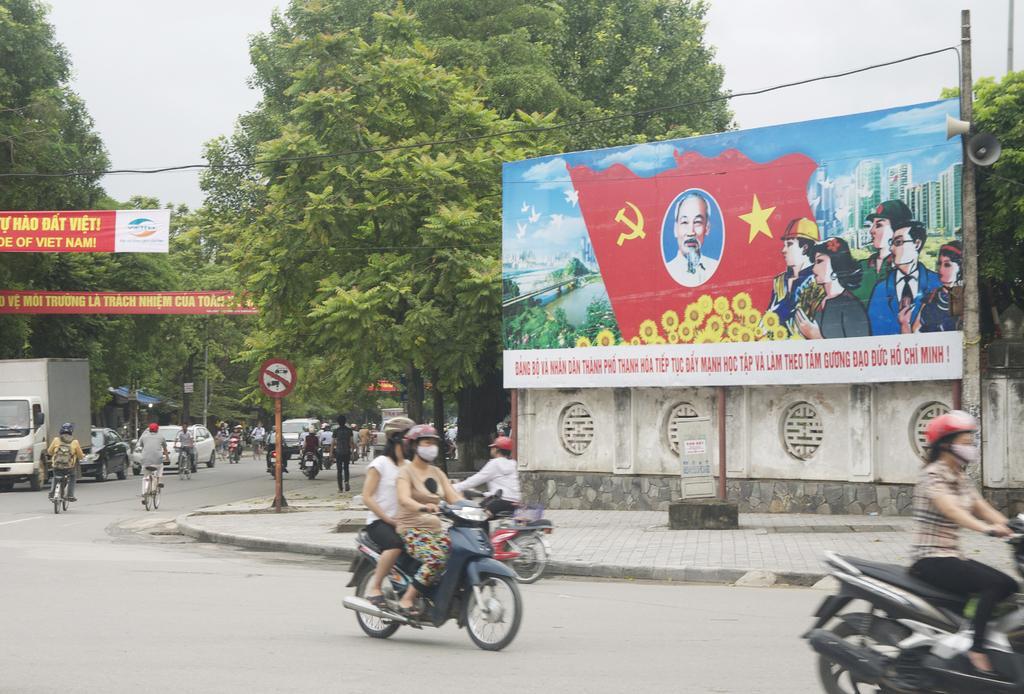How would you summarize this image in a sentence or two? There were too many vehicles moving on a road. To the right there is a bike and a woman riding on it wears a red helmet. In the center there is a bike and two people were riding on it and there were helmets and beside them,there is a bike and a person riding on it and he wears a red helmet. To the top right there is a hoarding consists of a person's, symbols, flowers, birds, bridge, buildings and group of cartoons and a printed text on it. There are two sound speakers attached to the hoarding. In the background there were two trees. To the left there are two banners and printed text on it. To the bottom left there are group of vehicles consists of truck, bicycles, car and bikes. There is a signal board in the center. 